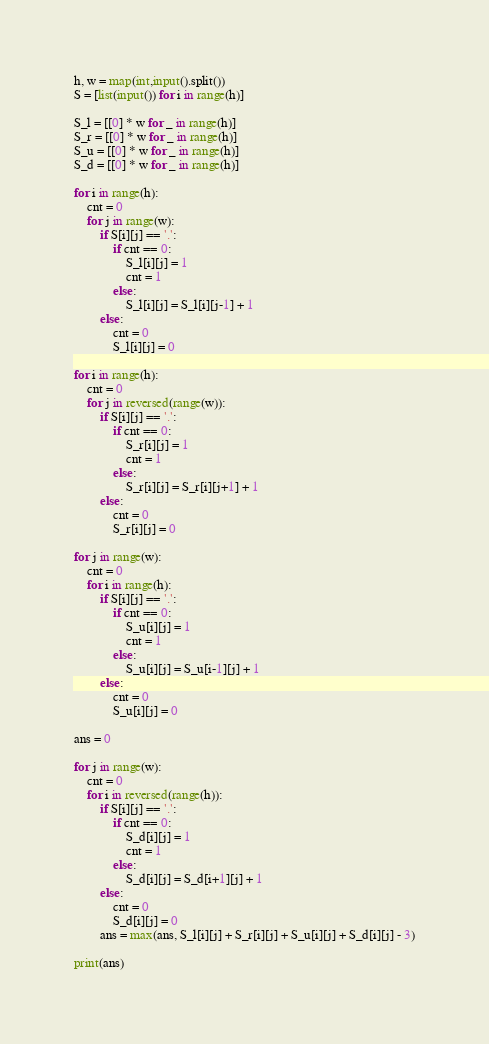<code> <loc_0><loc_0><loc_500><loc_500><_Python_>h, w = map(int,input().split())
S = [list(input()) for i in range(h)]

S_l = [[0] * w for _ in range(h)]
S_r = [[0] * w for _ in range(h)]
S_u = [[0] * w for _ in range(h)]
S_d = [[0] * w for _ in range(h)]

for i in range(h):
    cnt = 0
    for j in range(w):
        if S[i][j] == '.':
            if cnt == 0:
                S_l[i][j] = 1
                cnt = 1
            else:
                S_l[i][j] = S_l[i][j-1] + 1
        else:
            cnt = 0
            S_l[i][j] = 0

for i in range(h):
    cnt = 0
    for j in reversed(range(w)):
        if S[i][j] == '.':
            if cnt == 0:
                S_r[i][j] = 1
                cnt = 1
            else:
                S_r[i][j] = S_r[i][j+1] + 1
        else:
            cnt = 0
            S_r[i][j] = 0

for j in range(w):
    cnt = 0
    for i in range(h):
        if S[i][j] == '.':
            if cnt == 0:
                S_u[i][j] = 1
                cnt = 1
            else:
                S_u[i][j] = S_u[i-1][j] + 1
        else:
            cnt = 0
            S_u[i][j] = 0

ans = 0

for j in range(w):
    cnt = 0
    for i in reversed(range(h)):
        if S[i][j] == '.':
            if cnt == 0:
                S_d[i][j] = 1
                cnt = 1
            else:
                S_d[i][j] = S_d[i+1][j] + 1
        else:
            cnt = 0
            S_d[i][j] = 0
        ans = max(ans, S_l[i][j] + S_r[i][j] + S_u[i][j] + S_d[i][j] - 3)

print(ans)</code> 